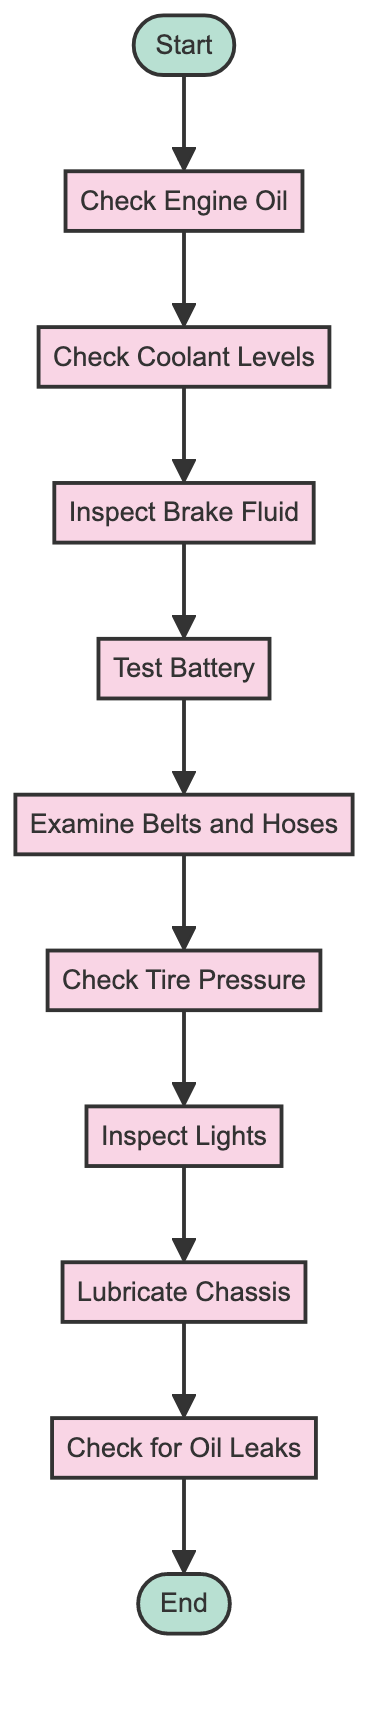What is the first action in the routine maintenance checklist? The diagram indicates that the first action after the initial node "Start" is "Check Engine Oil." This is deduced by following the directed arrow from "Start" to the next node.
Answer: Check Engine Oil How many actions are listed in the checklist? By counting the action nodes from "Check Engine Oil" to "Check for Oil Leaks," there are a total of 9 actions in the diagram. This includes all listed actions before reaching the "End" node.
Answer: 9 Which action comes immediately after "Inspect Brake Fluid"? The arrow in the diagram shows that after "Inspect Brake Fluid," the next action is "Test Battery." Following the flow of the diagram, this is straightforward to conclude.
Answer: Test Battery What action precedes "Check Tire Pressure"? The diagram shows that "Examine Belts and Hoses" is the action that occurs before "Check Tire Pressure." The flow of actions helps in determining this relationship.
Answer: Examine Belts and Hoses What is the final node in the routine maintenance checklist? The final node in the diagram is labeled "End." This is indicated as the concluding node, which signifies the completion of the checklist sequence.
Answer: End How many actions are needed to reach the final "End" node? To reach the "End" node, all actions listed in the sequence must be followed, totaling 9 actions. This is counted by tracking the progression from the first action to the final node.
Answer: 9 What action follows "Inspect Lights"? According to the flow direction in the diagram, "Lubricate Chassis" is the action that follows "Inspect Lights." This is determined by observing the arrows connecting the nodes.
Answer: Lubricate Chassis Is "Check for Oil Leaks" connected directly to "Check Engine Oil"? No, "Check for Oil Leaks" is not directly connected to "Check Engine Oil." The flow sequence indicates that several actions are performed in between before reaching "Check for Oil Leaks."
Answer: No 